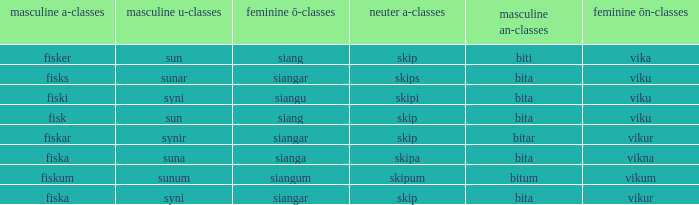What is the an-stem for the word which has an ö-stems of siangar and an u-stem ending of syni? Bita. 